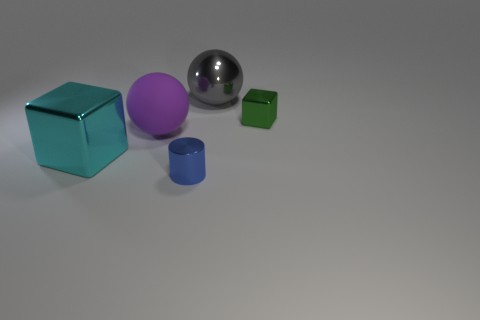Do the green object and the gray thing have the same material?
Offer a terse response. Yes. Are there any spheres on the right side of the large gray ball?
Give a very brief answer. No. What is the material of the cube that is in front of the cube that is to the right of the gray thing?
Give a very brief answer. Metal. What size is the cyan metallic thing that is the same shape as the green object?
Make the answer very short. Large. Does the big metallic block have the same color as the tiny cylinder?
Keep it short and to the point. No. The thing that is behind the large purple ball and to the left of the small green object is what color?
Make the answer very short. Gray. Is the size of the ball that is behind the green block the same as the purple ball?
Make the answer very short. Yes. Is there anything else that has the same shape as the green metal thing?
Provide a short and direct response. Yes. Do the cyan object and the sphere that is behind the big purple rubber object have the same material?
Provide a short and direct response. Yes. What number of green objects are metallic blocks or big balls?
Offer a very short reply. 1. 